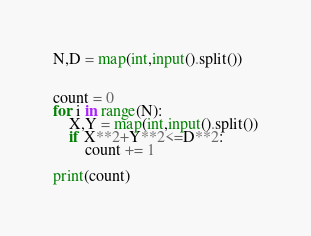<code> <loc_0><loc_0><loc_500><loc_500><_Python_>N,D = map(int,input().split())


count = 0
for i in range(N):
    X,Y = map(int,input().split())
    if X**2+Y**2<=D**2:
        count += 1

print(count)</code> 